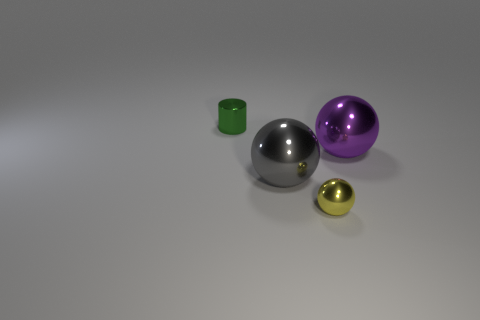Add 3 big purple objects. How many objects exist? 7 Subtract all cylinders. How many objects are left? 3 Subtract all yellow metallic objects. Subtract all green things. How many objects are left? 2 Add 2 objects. How many objects are left? 6 Add 3 purple balls. How many purple balls exist? 4 Subtract 0 purple cylinders. How many objects are left? 4 